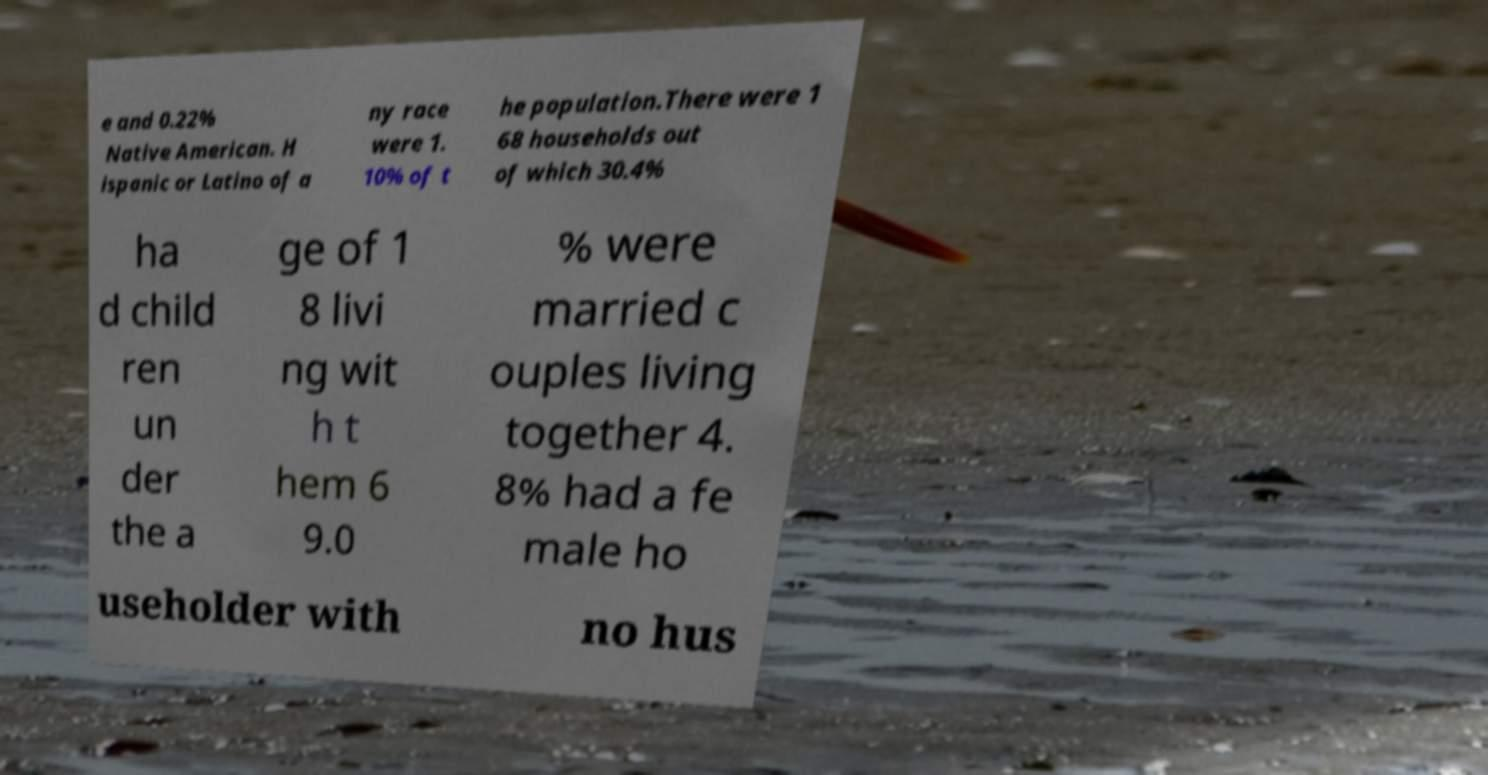What messages or text are displayed in this image? I need them in a readable, typed format. e and 0.22% Native American. H ispanic or Latino of a ny race were 1. 10% of t he population.There were 1 68 households out of which 30.4% ha d child ren un der the a ge of 1 8 livi ng wit h t hem 6 9.0 % were married c ouples living together 4. 8% had a fe male ho useholder with no hus 